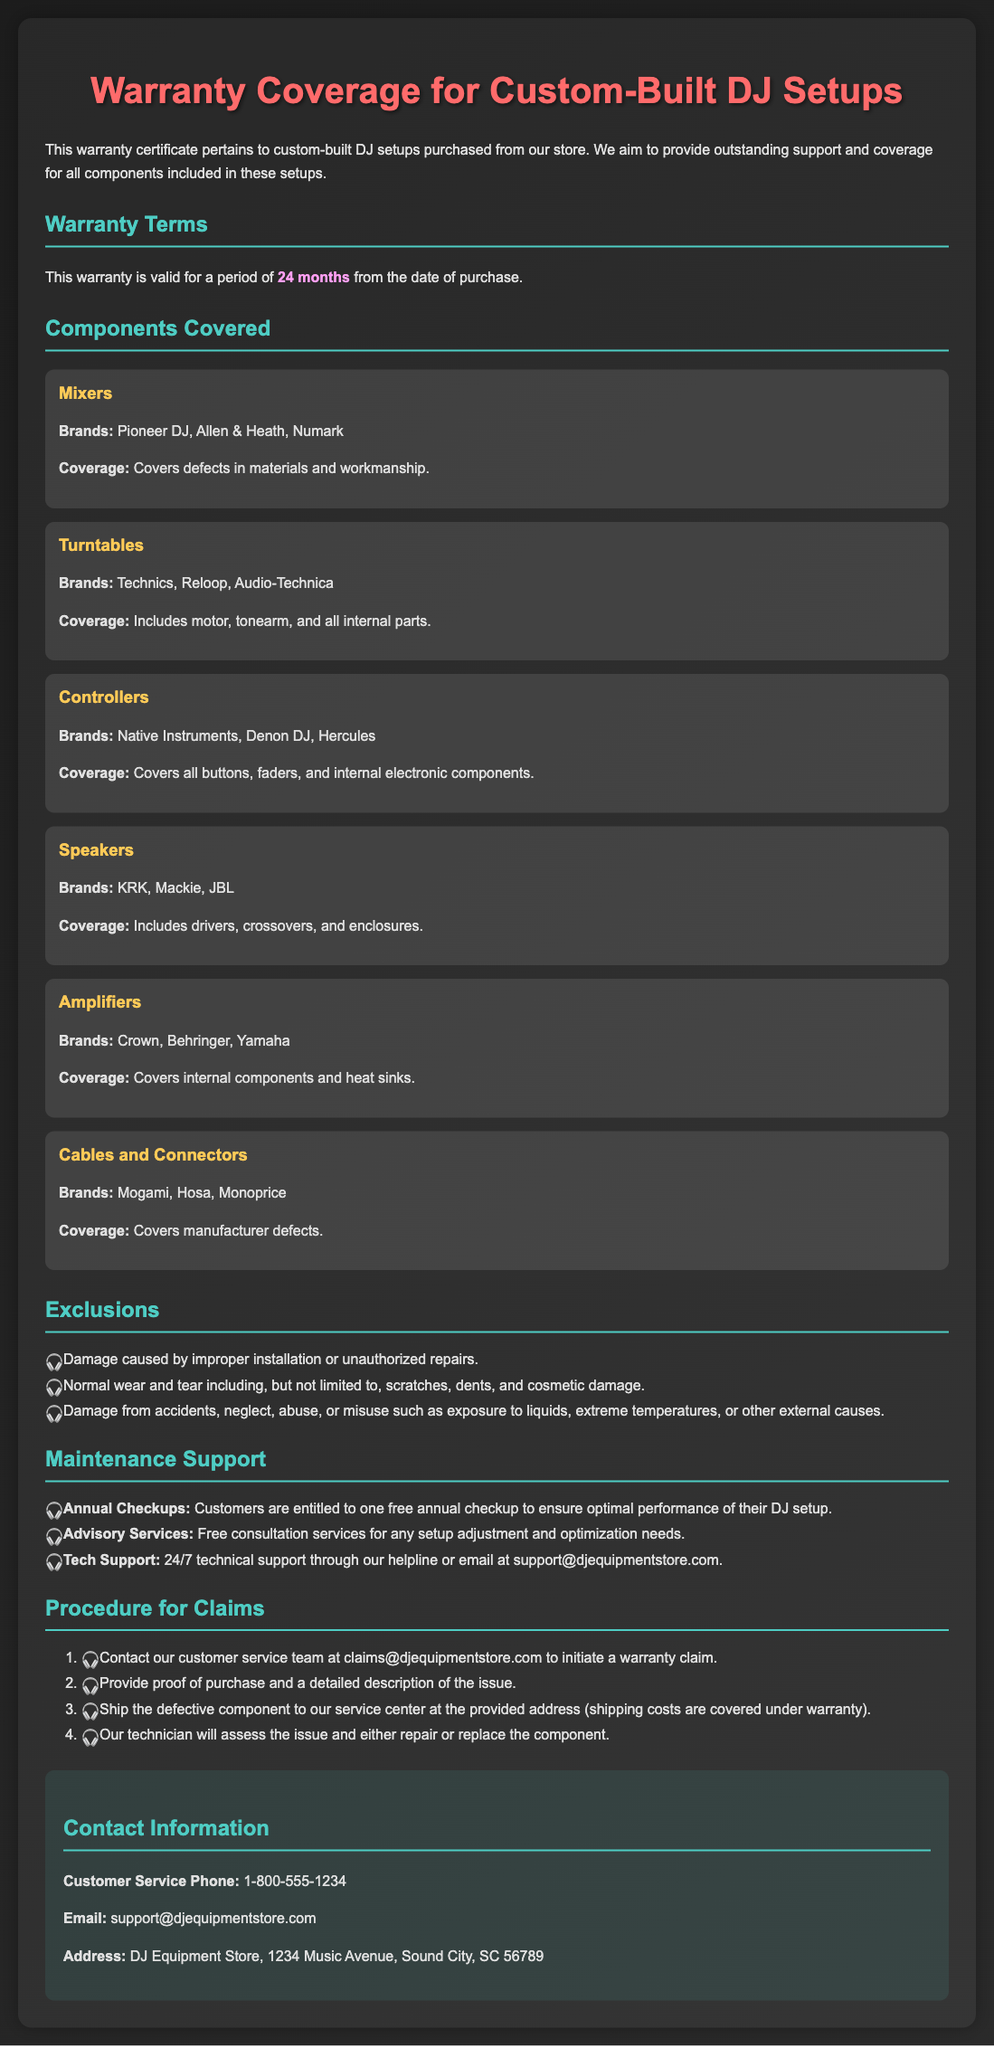What is the duration of the warranty? The warranty is valid for a period of 24 months from the date of purchase.
Answer: 24 months Which brand of mixers is covered under the warranty? The warranty covers mixers from brands such as Pioneer DJ, Allen & Heath, and Numark.
Answer: Pioneer DJ, Allen & Heath, Numark What type of maintenance support is included annually? Customers are entitled to one free annual checkup to ensure optimal performance of their DJ setup.
Answer: One free annual checkup What component is specifically excluded from warranty claims? Damage caused by improper installation or unauthorized repairs is excluded from warranty claims.
Answer: Improper installation How should customers initiate a warranty claim? Customers should contact customer service at claims@djequipmentstore.com to initiate a warranty claim.
Answer: claims@djequipmentstore.com What coverage does the warranty provide for amplifiers? The warranty covers internal components and heat sinks of amplifiers.
Answer: Internal components and heat sinks Which support is available 24/7 for customers? The warranty includes 24/7 technical support through the helpline or email.
Answer: 24/7 technical support Which components are covered under the warranty? The warranty covers mixers, turntables, controllers, speakers, amplifiers, and cables and connectors.
Answer: Mixers, turntables, controllers, speakers, amplifiers, cables and connectors What kind of damage is classified as normal wear and tear? Normal wear and tear includes scratches, dents, and cosmetic damage.
Answer: Scratches, dents, and cosmetic damage 